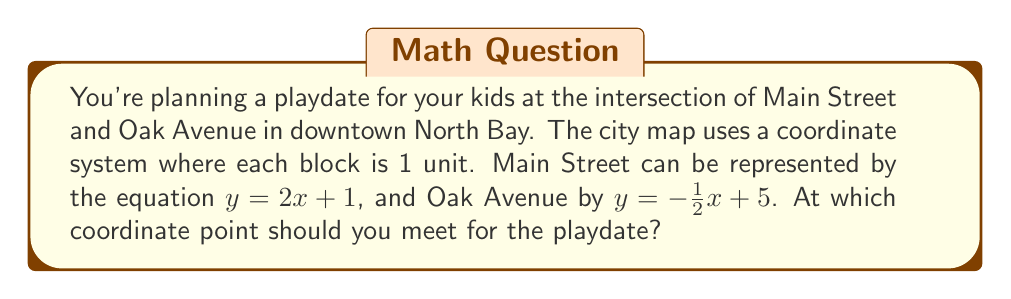Can you solve this math problem? To find the intersection point of Main Street and Oak Avenue, we need to solve the system of equations:

1) Main Street: $y = 2x + 1$
2) Oak Avenue: $y = -\frac{1}{2}x + 5$

Steps to solve:

1. Set the equations equal to each other:
   $2x + 1 = -\frac{1}{2}x + 5$

2. Multiply both sides by 2 to eliminate fractions:
   $4x + 2 = -x + 10$

3. Add $x$ to both sides:
   $5x + 2 = 10$

4. Subtract 2 from both sides:
   $5x = 8$

5. Divide both sides by 5:
   $x = \frac{8}{5} = 1.6$

6. Substitute this x-value into either original equation. Let's use Main Street:
   $y = 2(1.6) + 1 = 3.2 + 1 = 4.2$

Therefore, the intersection point is $(1.6, 4.2)$.
Answer: $(1.6, 4.2)$ 